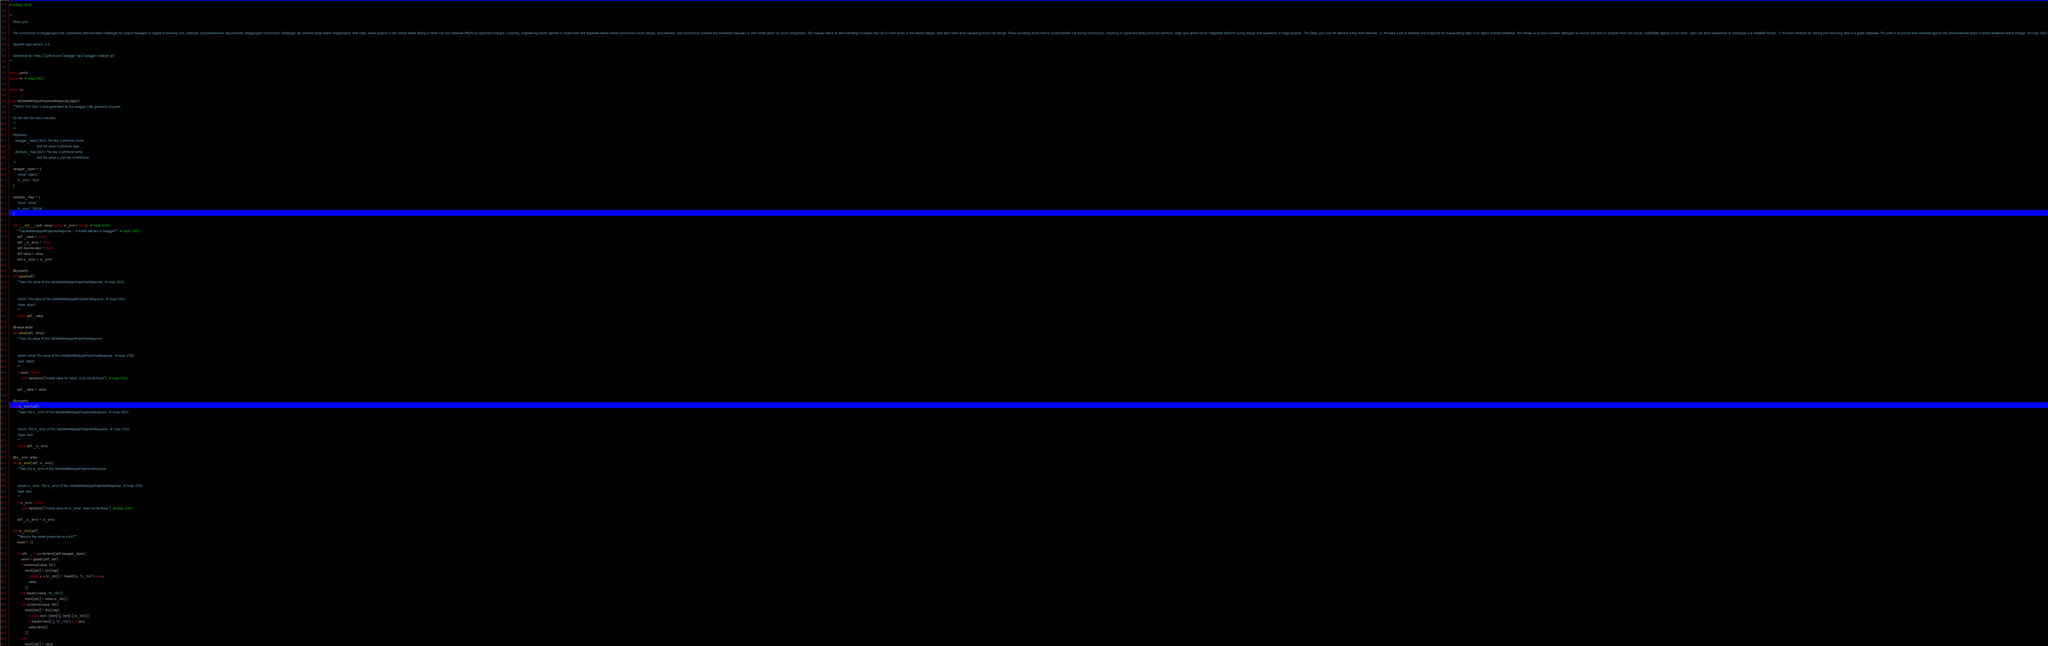Convert code to text. <code><loc_0><loc_0><loc_500><loc_500><_Python_># coding: utf-8

"""
    Deep Lynx

    The construction of megaprojects has consistently demonstrated challenges for project managers in regard to meeting cost, schedule, and performance requirements. Megaproject construction challenges are common place within megaprojects with many active projects in the United States failing to meet cost and schedule efforts by significant margins. Currently, engineering teams operate in siloed tools and disparate teams where connections across design, procurement, and construction systems are translated manually or over brittle point-to-point integrations. The manual nature of data exchange increases the risk of silent errors in the reactor design, with each silent error cascading across the design. These cascading errors lead to uncontrollable risk during construction, resulting in significant delays and cost overruns. Deep Lynx allows for an integrated platform during design and operations of mega projects.  The Deep Lynx Core API delivers a few main features.  1. Provides a set of methods and endpoints for manipulating data in an object oriented database. This allows us to store complex datatypes as records and then to compile them into actual, modifiable objects at run-time. Users can store taxonomies or ontologies in a readable format.  2. Provides methods for storing and retrieving data in a graph database. This data is structured and validated against the aformentioned object oriented database before storage.  # noqa: E501

    OpenAPI spec version: 1.0
    
    Generated by: https://github.com/swagger-api/swagger-codegen.git
"""

import pprint
import re  # noqa: F401

import six

class ValidateMetatypePropertiesResponse(object):
    """NOTE: This class is auto generated by the swagger code generator program.

    Do not edit the class manually.
    """
    """
    Attributes:
      swagger_types (dict): The key is attribute name
                            and the value is attribute type.
      attribute_map (dict): The key is attribute name
                            and the value is json key in definition.
    """
    swagger_types = {
        'value': 'object',
        'is_error': 'bool'
    }

    attribute_map = {
        'value': 'value',
        'is_error': 'isError'
    }

    def __init__(self, value=None, is_error=None):  # noqa: E501
        """ValidateMetatypePropertiesResponse - a model defined in Swagger"""  # noqa: E501
        self._value = None
        self._is_error = None
        self.discriminator = None
        self.value = value
        self.is_error = is_error

    @property
    def value(self):
        """Gets the value of this ValidateMetatypePropertiesResponse.  # noqa: E501


        :return: The value of this ValidateMetatypePropertiesResponse.  # noqa: E501
        :rtype: object
        """
        return self._value

    @value.setter
    def value(self, value):
        """Sets the value of this ValidateMetatypePropertiesResponse.


        :param value: The value of this ValidateMetatypePropertiesResponse.  # noqa: E501
        :type: object
        """
        if value is None:
            raise ValueError("Invalid value for `value`, must not be `None`")  # noqa: E501

        self._value = value

    @property
    def is_error(self):
        """Gets the is_error of this ValidateMetatypePropertiesResponse.  # noqa: E501


        :return: The is_error of this ValidateMetatypePropertiesResponse.  # noqa: E501
        :rtype: bool
        """
        return self._is_error

    @is_error.setter
    def is_error(self, is_error):
        """Sets the is_error of this ValidateMetatypePropertiesResponse.


        :param is_error: The is_error of this ValidateMetatypePropertiesResponse.  # noqa: E501
        :type: bool
        """
        if is_error is None:
            raise ValueError("Invalid value for `is_error`, must not be `None`")  # noqa: E501

        self._is_error = is_error

    def to_dict(self):
        """Returns the model properties as a dict"""
        result = {}

        for attr, _ in six.iteritems(self.swagger_types):
            value = getattr(self, attr)
            if isinstance(value, list):
                result[attr] = list(map(
                    lambda x: x.to_dict() if hasattr(x, "to_dict") else x,
                    value
                ))
            elif hasattr(value, "to_dict"):
                result[attr] = value.to_dict()
            elif isinstance(value, dict):
                result[attr] = dict(map(
                    lambda item: (item[0], item[1].to_dict())
                    if hasattr(item[1], "to_dict") else item,
                    value.items()
                ))
            else:
                result[attr] = value</code> 